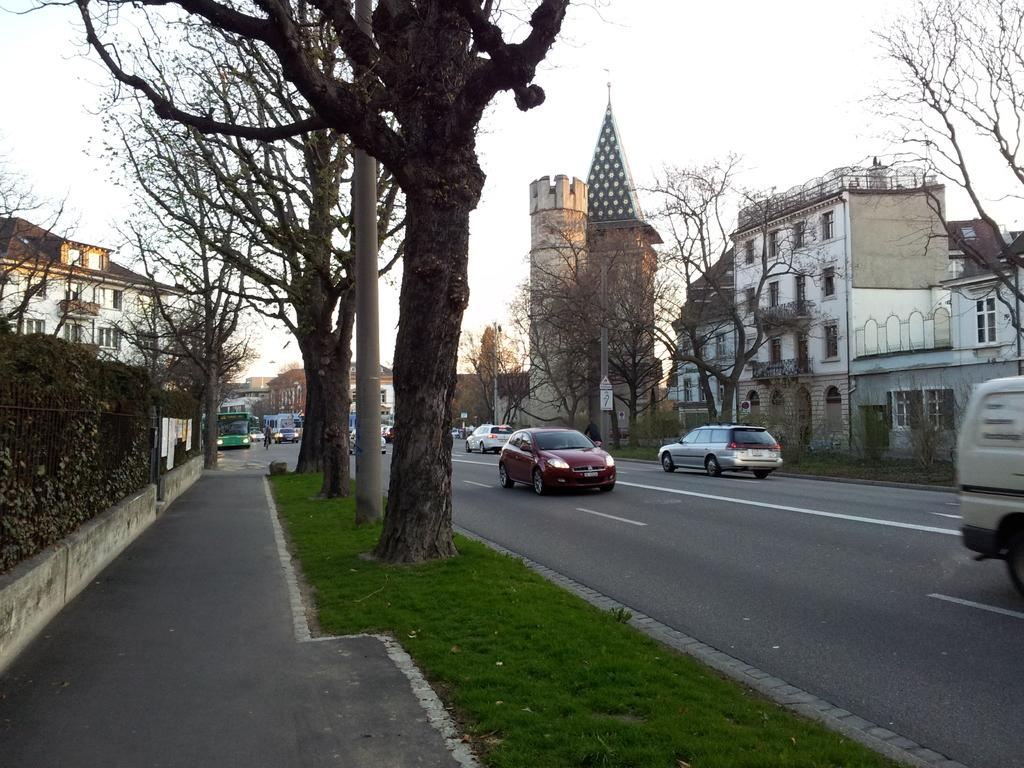What can be seen on the road in the image? There are vehicles on the road in the image. What is located beside the road in the image? There are trees beside the road in the image. What type of structures are present in the image? There are buildings in the image. What else can be seen in the image besides the vehicles, trees, and buildings? There are poles in the image. Can you tell me where the cloud is located in the image? There is no cloud present in the image. What type of agreement is being made between the buildings in the image? There is no agreement being made between the buildings in the image; they are simply structures. 